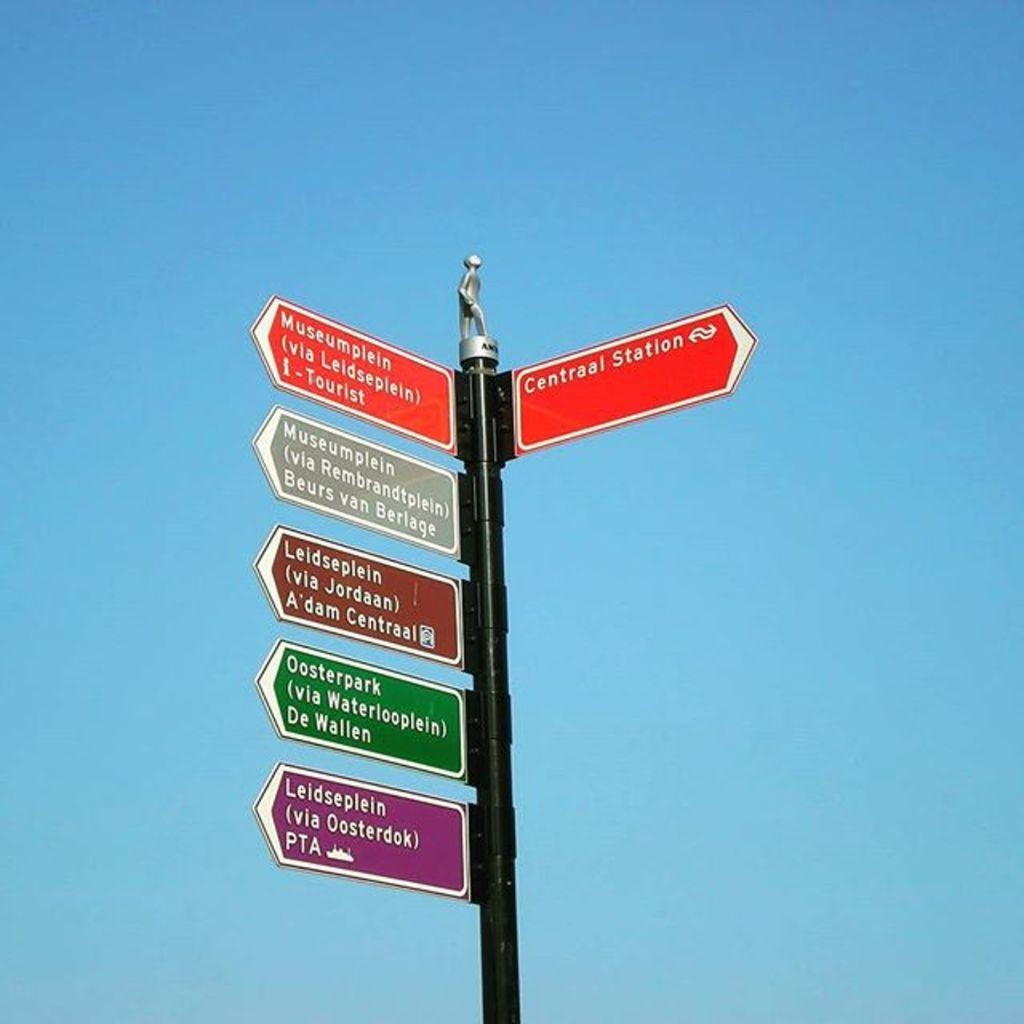Provide a one-sentence caption for the provided image. Several signs are on a post, including one for Centraal Station. 